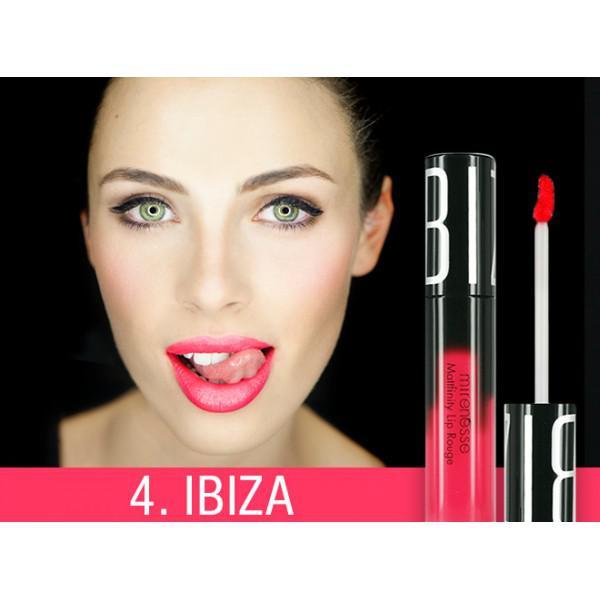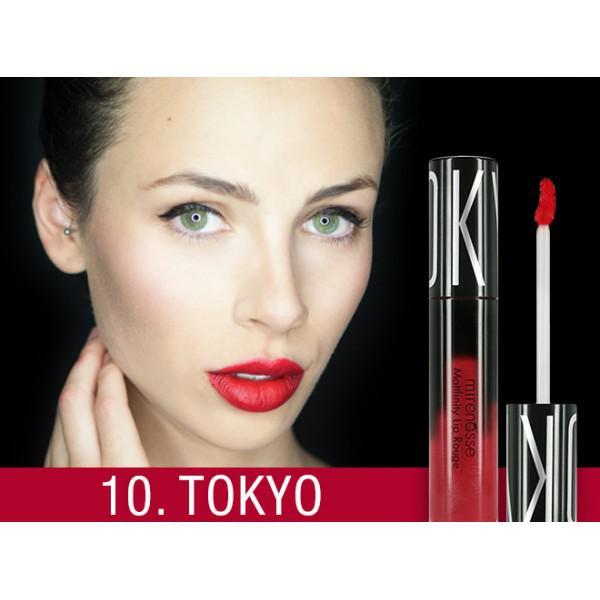The first image is the image on the left, the second image is the image on the right. Analyze the images presented: Is the assertion "One image shows a model with tinted lips that are closed, so no teeth show." valid? Answer yes or no. No. 